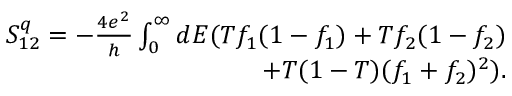<formula> <loc_0><loc_0><loc_500><loc_500>\begin{array} { r } { { S _ { 1 2 } ^ { q } = - \frac { 4 e ^ { 2 } } { h } \int _ { 0 } ^ { \infty } d E ( T f _ { 1 } ( 1 - f _ { 1 } ) + T f _ { 2 } ( 1 - f _ { 2 } ) } } \\ { { + T ( 1 - T ) ( f _ { 1 } + f _ { 2 } ) ^ { 2 } ) } . } \end{array}</formula> 